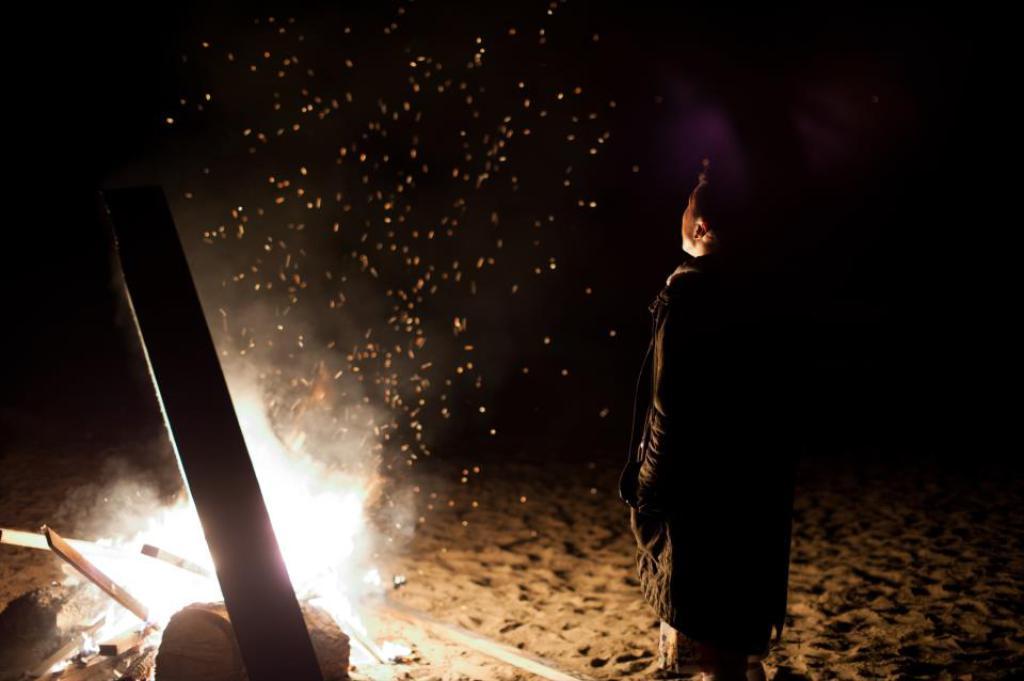Can you describe this image briefly? In the image there is a person standing on sandy land with a campfire in front of him. 